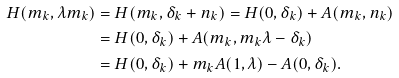<formula> <loc_0><loc_0><loc_500><loc_500>H ( m _ { k } , \lambda m _ { k } ) & = H ( m _ { k } , \delta _ { k } + n _ { k } ) = H ( 0 , \delta _ { k } ) + A ( m _ { k } , n _ { k } ) \\ & = H ( 0 , \delta _ { k } ) + A ( m _ { k } , m _ { k } \lambda - \delta _ { k } ) \\ & = H ( 0 , \delta _ { k } ) + m _ { k } A ( 1 , \lambda ) - A ( 0 , \delta _ { k } ) .</formula> 